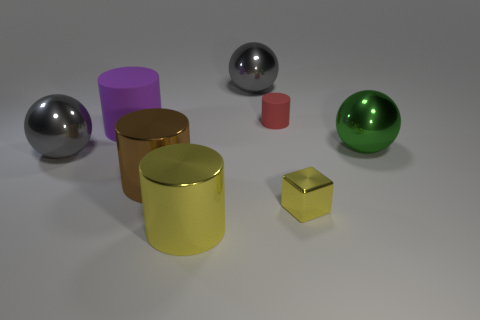There is a metallic object that is to the right of the metallic cube; is its size the same as the yellow cylinder?
Provide a short and direct response. Yes. What number of other objects are the same material as the large green ball?
Offer a very short reply. 5. Is the number of big yellow metallic cylinders that are in front of the small red object the same as the number of tiny rubber cylinders that are in front of the yellow cylinder?
Give a very brief answer. No. What is the color of the large metallic thing that is on the right side of the big gray shiny sphere that is behind the large metal thing that is on the left side of the large purple rubber cylinder?
Offer a terse response. Green. There is a matte object to the left of the big yellow metal object; what shape is it?
Offer a terse response. Cylinder. What is the shape of the purple thing that is the same material as the tiny red cylinder?
Offer a very short reply. Cylinder. Is there any other thing that is the same shape as the purple matte object?
Offer a very short reply. Yes. How many tiny red rubber cylinders are to the left of the large brown thing?
Your response must be concise. 0. Is the number of large yellow cylinders that are to the left of the big yellow object the same as the number of brown cylinders?
Your answer should be very brief. No. Is the material of the brown cylinder the same as the large yellow cylinder?
Offer a terse response. Yes. 